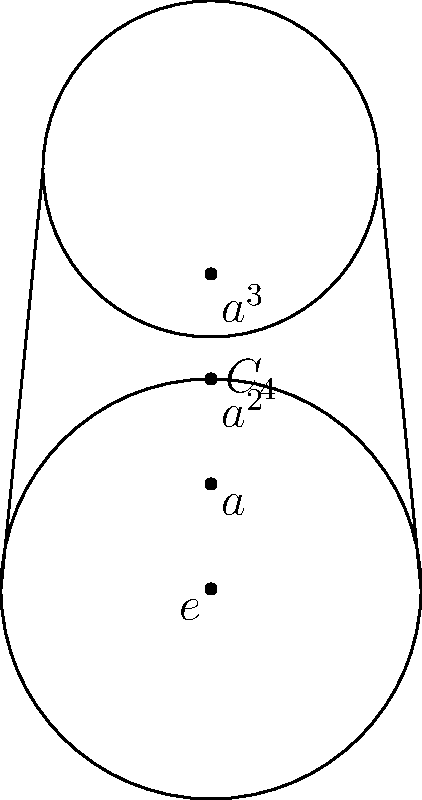An ancient Irish round tower exhibits a cyclic group structure in its design. The tower's cross-section can be rotated by 90° increments, forming a cyclic group of order 4. If 'e' represents the identity element (no rotation) and 'a' represents a 90° clockwise rotation, what element of the group corresponds to a 270° clockwise rotation? Let's approach this step-by-step:

1) First, we need to understand the cyclic group $C_4$ represented by the tower's rotational symmetry:
   - $e$: identity element (0° rotation)
   - $a$: 90° clockwise rotation
   - $a^2$: 180° clockwise rotation
   - $a^3$: 270° clockwise rotation

2) In this group, each application of 'a' rotates the tower by 90° clockwise.

3) To achieve a 270° clockwise rotation, we need to apply the 90° rotation three times:
   $a * a * a = a^3$

4) Alternatively, we can think of 270° clockwise as equivalent to 90° counterclockwise:
   $(a^{-1}) = a^3$ in $C_4$

5) Both methods lead to the same result: $a^3$

Therefore, a 270° clockwise rotation corresponds to the element $a^3$ in the group.
Answer: $a^3$ 